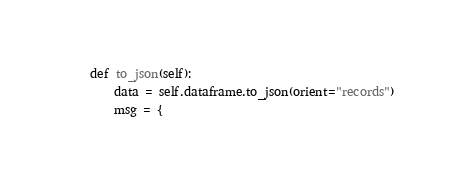<code> <loc_0><loc_0><loc_500><loc_500><_Python_>    def to_json(self):
        data = self.dataframe.to_json(orient="records")
        msg = {</code> 